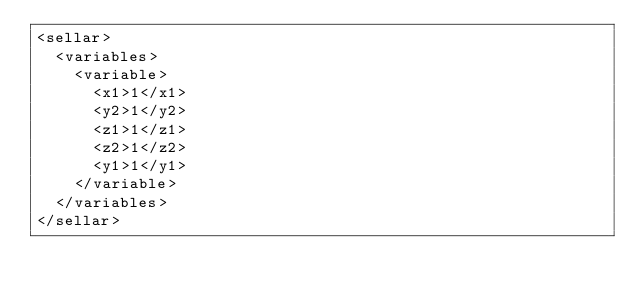Convert code to text. <code><loc_0><loc_0><loc_500><loc_500><_XML_><sellar>
  <variables>
    <variable>
      <x1>1</x1>
      <y2>1</y2>
      <z1>1</z1>
      <z2>1</z2>
      <y1>1</y1>
    </variable>
  </variables>
</sellar>
</code> 